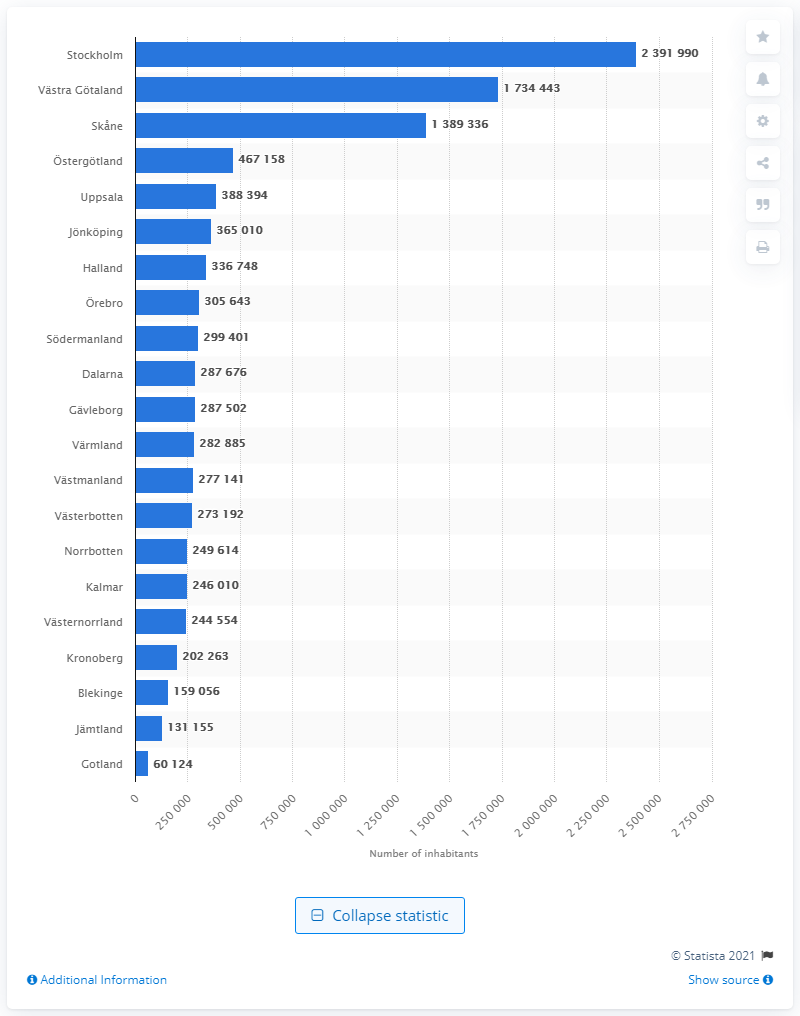Indicate a few pertinent items in this graphic. The population of Stockholm county is approximately 2,391,990. The population of Skne county is 138,9336 individuals. 